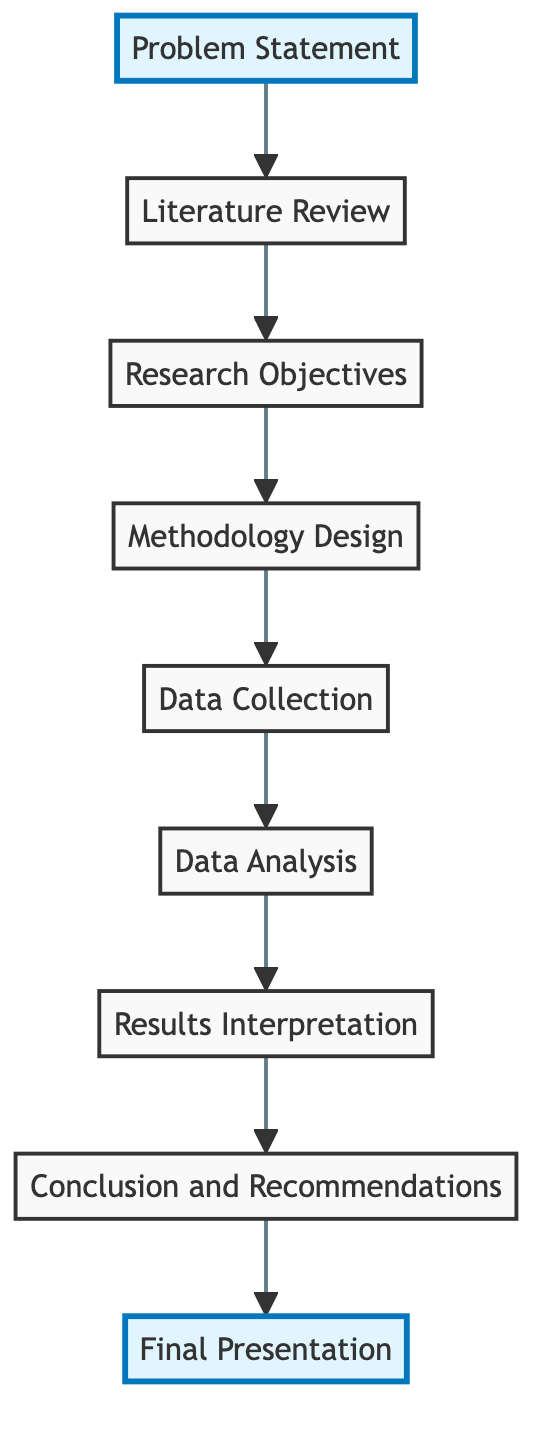What is the first step in the research project flow? The first step in the research project flow is "Problem Statement," as indicated at the bottom of the diagram. It outlines the importance of defining the research problem clearly.
Answer: Problem Statement How many nodes are present in the flowchart? By counting each distinct component in the diagram starting from the bottom, we find there are a total of 9 nodes: Problem Statement, Literature Review, Research Objectives, Methodology Design, Data Collection, Data Analysis, Results Interpretation, Conclusion and Recommendations, and Final Presentation.
Answer: 9 What follows after "Data Collection"? Following "Data Collection," the next step in the flow is "Data Analysis," where the gathered data is analyzed using appropriate techniques.
Answer: Data Analysis Which node directly precedes "Final Presentation"? "Conclusion and Recommendations" directly precedes "Final Presentation," indicating that conclusions must be drawn before the presentation can be prepared.
Answer: Conclusion and Recommendations In what order do the steps occur from the problem statement to the final presentation? The order begins with "Problem Statement," moving up through "Literature Review," "Research Objectives," "Methodology Design," "Data Collection," "Data Analysis," "Results Interpretation," and "Conclusion and Recommendations" before reaching "Final Presentation," showing a clear and sequential progression of research activities.
Answer: Problem Statement, Literature Review, Research Objectives, Methodology Design, Data Collection, Data Analysis, Results Interpretation, Conclusion and Recommendations, Final Presentation What is the significance of the "Literature Review" step? The "Literature Review" step is significant as it involves reviewing existing research related to the problem, summarizing key findings, and identifying trends and gaps that inform the research objectives.
Answer: Summarizing key findings and identifying trends and gaps Which two nodes are highlighted in the diagram? The nodes highlighted in the diagram are "Problem Statement" at the bottom and "Final Presentation" at the top, emphasizing their importance as starting and concluding points in the research process flow.
Answer: Problem Statement, Final Presentation What kind of research methods are involved in the "Methodology Design"? The "Methodology Design" involves choosing appropriate research methods, which can be qualitative, quantitative, or mixed, to address the research objectives effectively.
Answer: Qualitative, quantitative, or mixed How does "Results Interpretation" relate to "Data Analysis"? "Results Interpretation" follows "Data Analysis" to ensure that the findings obtained from analyzing the data are evaluated in relation to the research objectives, illustrating a direct dependency between the two processes.
Answer: Data is interpreted based on the analysis results 